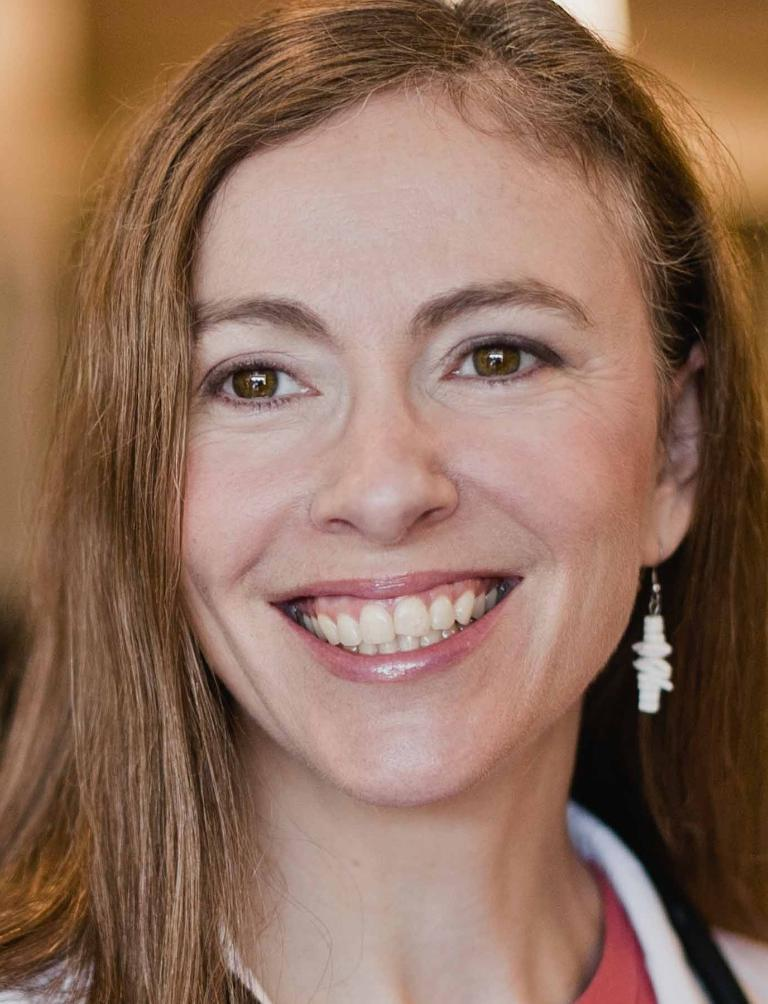Who is the main subject in the image? There is a woman in the image. What is the woman wearing? The woman is wearing a white dress. What expression does the woman have? The woman is smiling. Can you describe the background of the image? The background of the image is blurred. How many friends is the woman talking to in the image? There is no indication in the image that the woman is talking to any friends, as the image only shows her and the blurred background. 